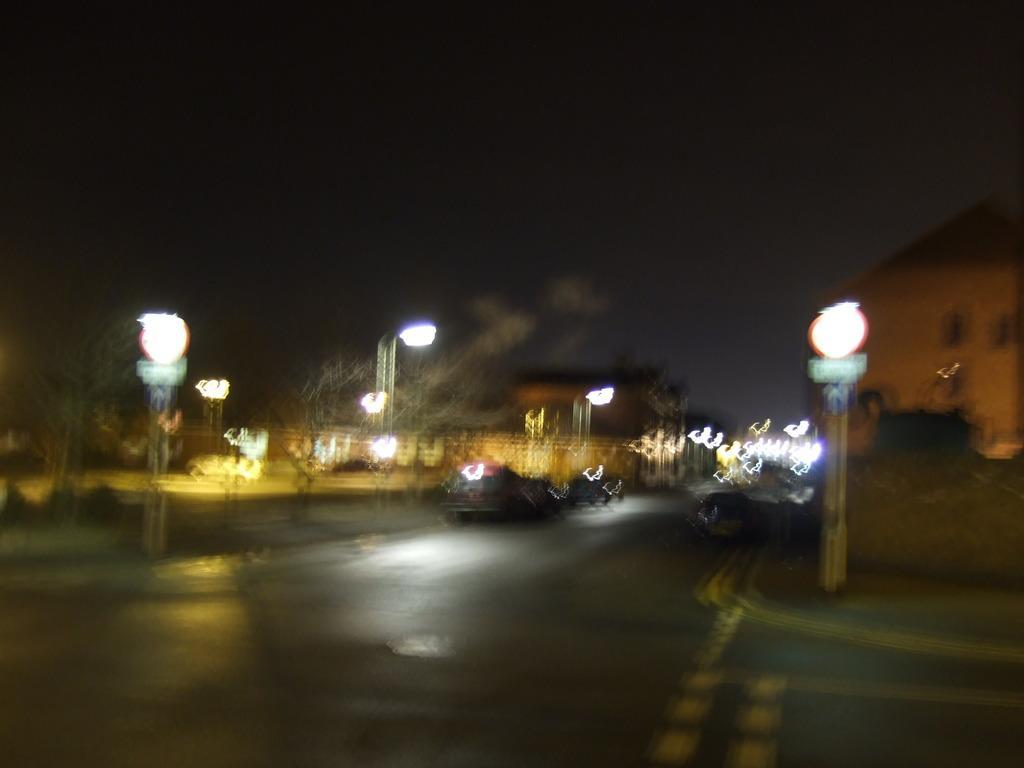In one or two sentences, can you explain what this image depicts? This is an image clicked in the dark. In the middle of the image I can see few cars on the road. On both sides of the road I can see few street lights. 